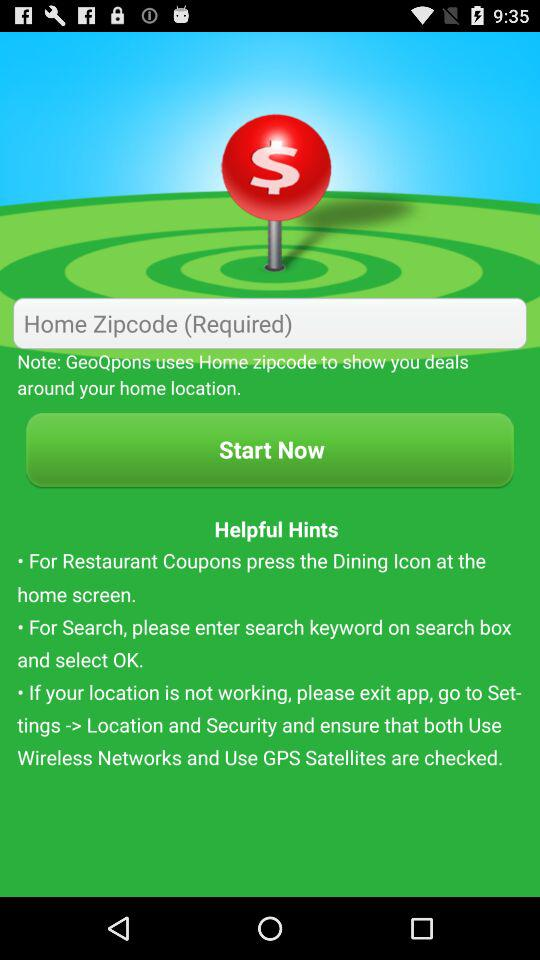Which icon is to be pressed on the home screen for restaurant coupons? The icon that is to be pressed on the home screen for restaurant coupons is "Dining". 